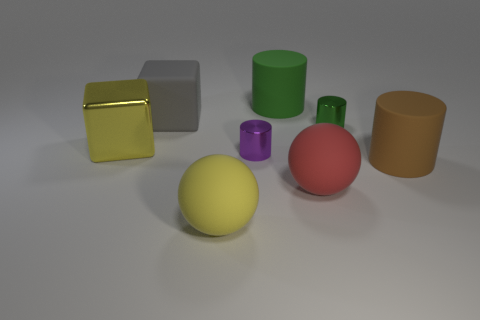Add 2 small purple shiny cylinders. How many objects exist? 10 Subtract all spheres. How many objects are left? 6 Subtract 0 blue spheres. How many objects are left? 8 Subtract all big brown rubber cylinders. Subtract all small cylinders. How many objects are left? 5 Add 8 brown objects. How many brown objects are left? 9 Add 7 large matte blocks. How many large matte blocks exist? 8 